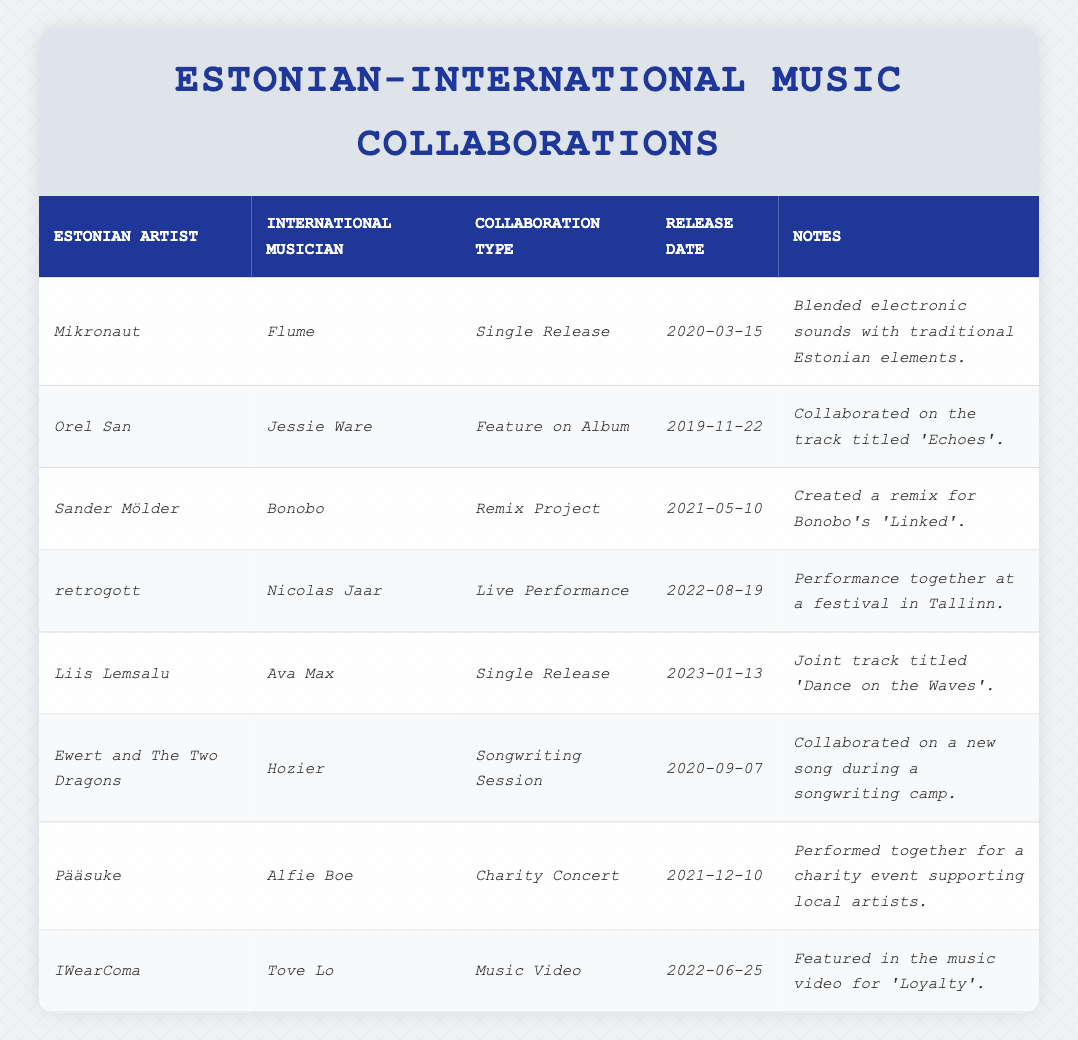What is the most recent collaboration listed in the table? The most recent collaboration can be found by looking at the "Release Date" column. The last date in chronological order is "2023-01-13," which corresponds to the collaboration between Liis Lemsalu and Ava Max.
Answer: Liis Lemsalu and Ava Max How many single releases are mentioned in the table? By checking the "Collaboration Type" column, we see that there are two entries listed as "Single Release" (Mikronaut with Flume and Liis Lemsalu with Ava Max). Count these entries to find the total.
Answer: 2 Which Estonian artist collaborated with international musician Hozier? The table indicates that Ewert and The Two Dragons worked with the international musician Hozier. This can be identified by finding Hozier in the "International Musician" column and looking across to find the corresponding Estonian artist.
Answer: Ewert and The Two Dragons Was there a collaboration involving Jessie Ware, and if so, what type was it? Yes, Jessie Ware collaborated with Orel San, as shown in the "International Musician" column. The collaboration type is noted as a "Feature on Album."
Answer: Yes, Feature on Album How many different types of collaboration are represented in the table? The collaboration types listed are Single Release, Feature on Album, Remix Project, Live Performance, Songwriting Session, Charity Concert, and Music Video. Counting these distinct types gives us seven in total.
Answer: 7 Which Estonian artist has been involved in a live performance with an international musician? The table shows that retrogott performed live with Nicolas Jaar, as indicated in the "Collaboration Type" column for that row.
Answer: retrogott What is the earliest collaboration mentioned in the table? To find the earliest collaboration, we check all the "Release Date" entries in chronological order. The earliest date is "2019-11-22," which corresponds to Orel San's collaboration with Jessie Ware.
Answer: Orel San and Jessie Ware Between which two artists did a charity concert occur? Pääsuke collaborated with Alfie Boe for a charity concert, as stated in the corresponding row under the collaboration details.
Answer: Pääsuke and Alfie Boe What kind of project did Sander Mölder and Bonobo work on together? The table indicates that Sander Mölder and Bonobo collaborated on a "Remix Project," which can be found in the "Collaboration Type" column for their entry.
Answer: Remix Project How many collaborations took place in 2022? From the "Release Date" entries, we see that there are three entries for the year 2022 (retrogott with Nicolas Jaar, IWearComa with Tove Lo, and the specific date for each can be checked). Counting those gives a total of three collaborations.
Answer: 3 